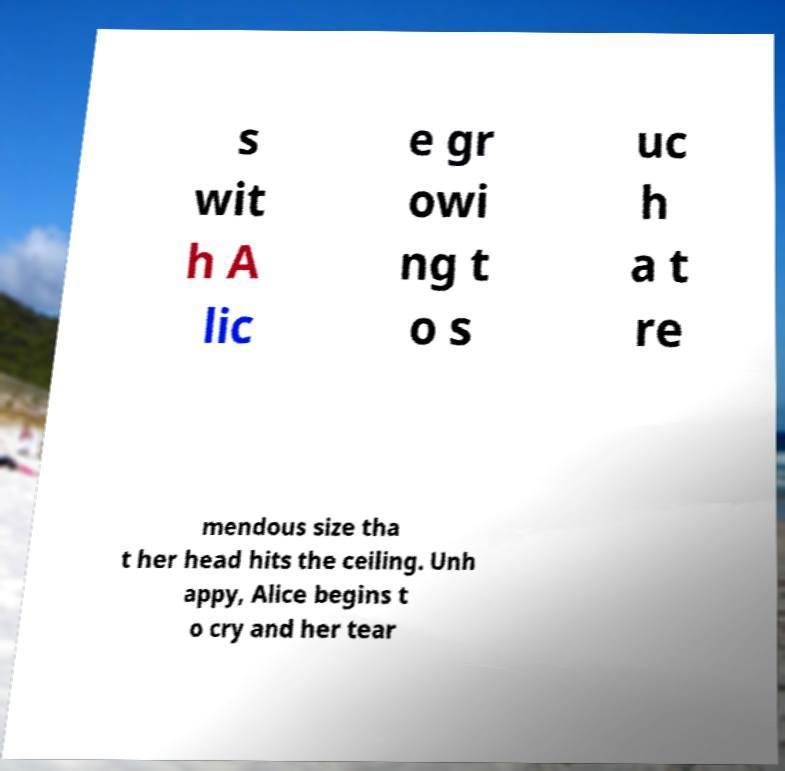Please read and relay the text visible in this image. What does it say? s wit h A lic e gr owi ng t o s uc h a t re mendous size tha t her head hits the ceiling. Unh appy, Alice begins t o cry and her tear 